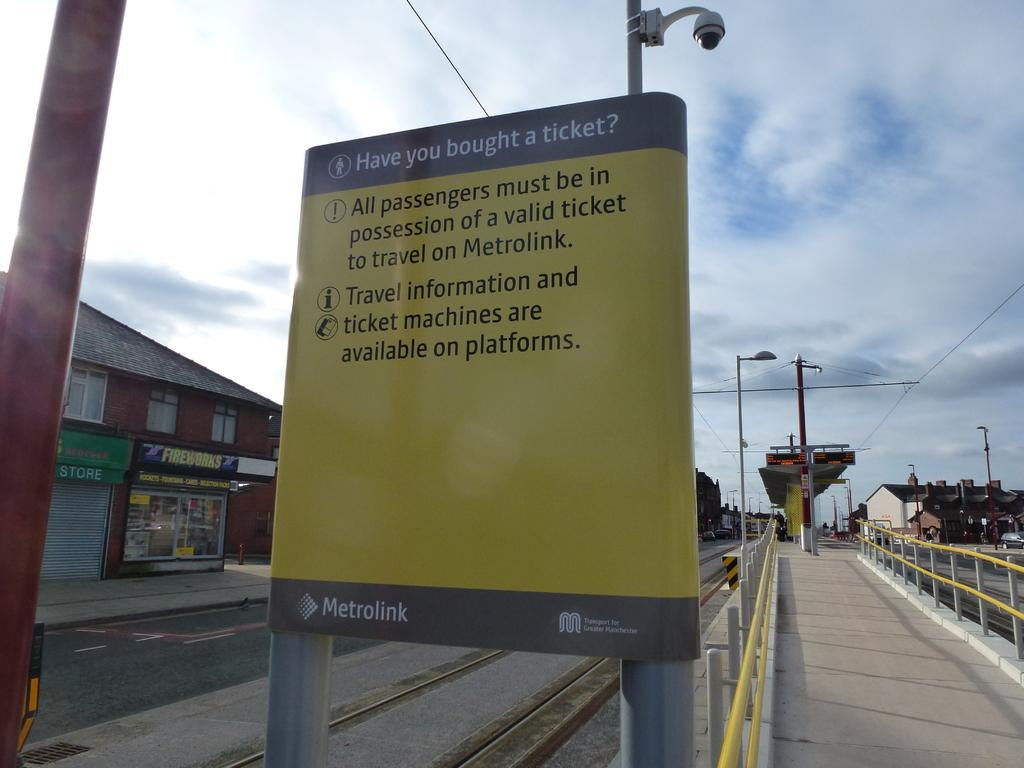<image>
Summarize the visual content of the image. The Metrolink sign has a question that says "have you brought a ticket?" 